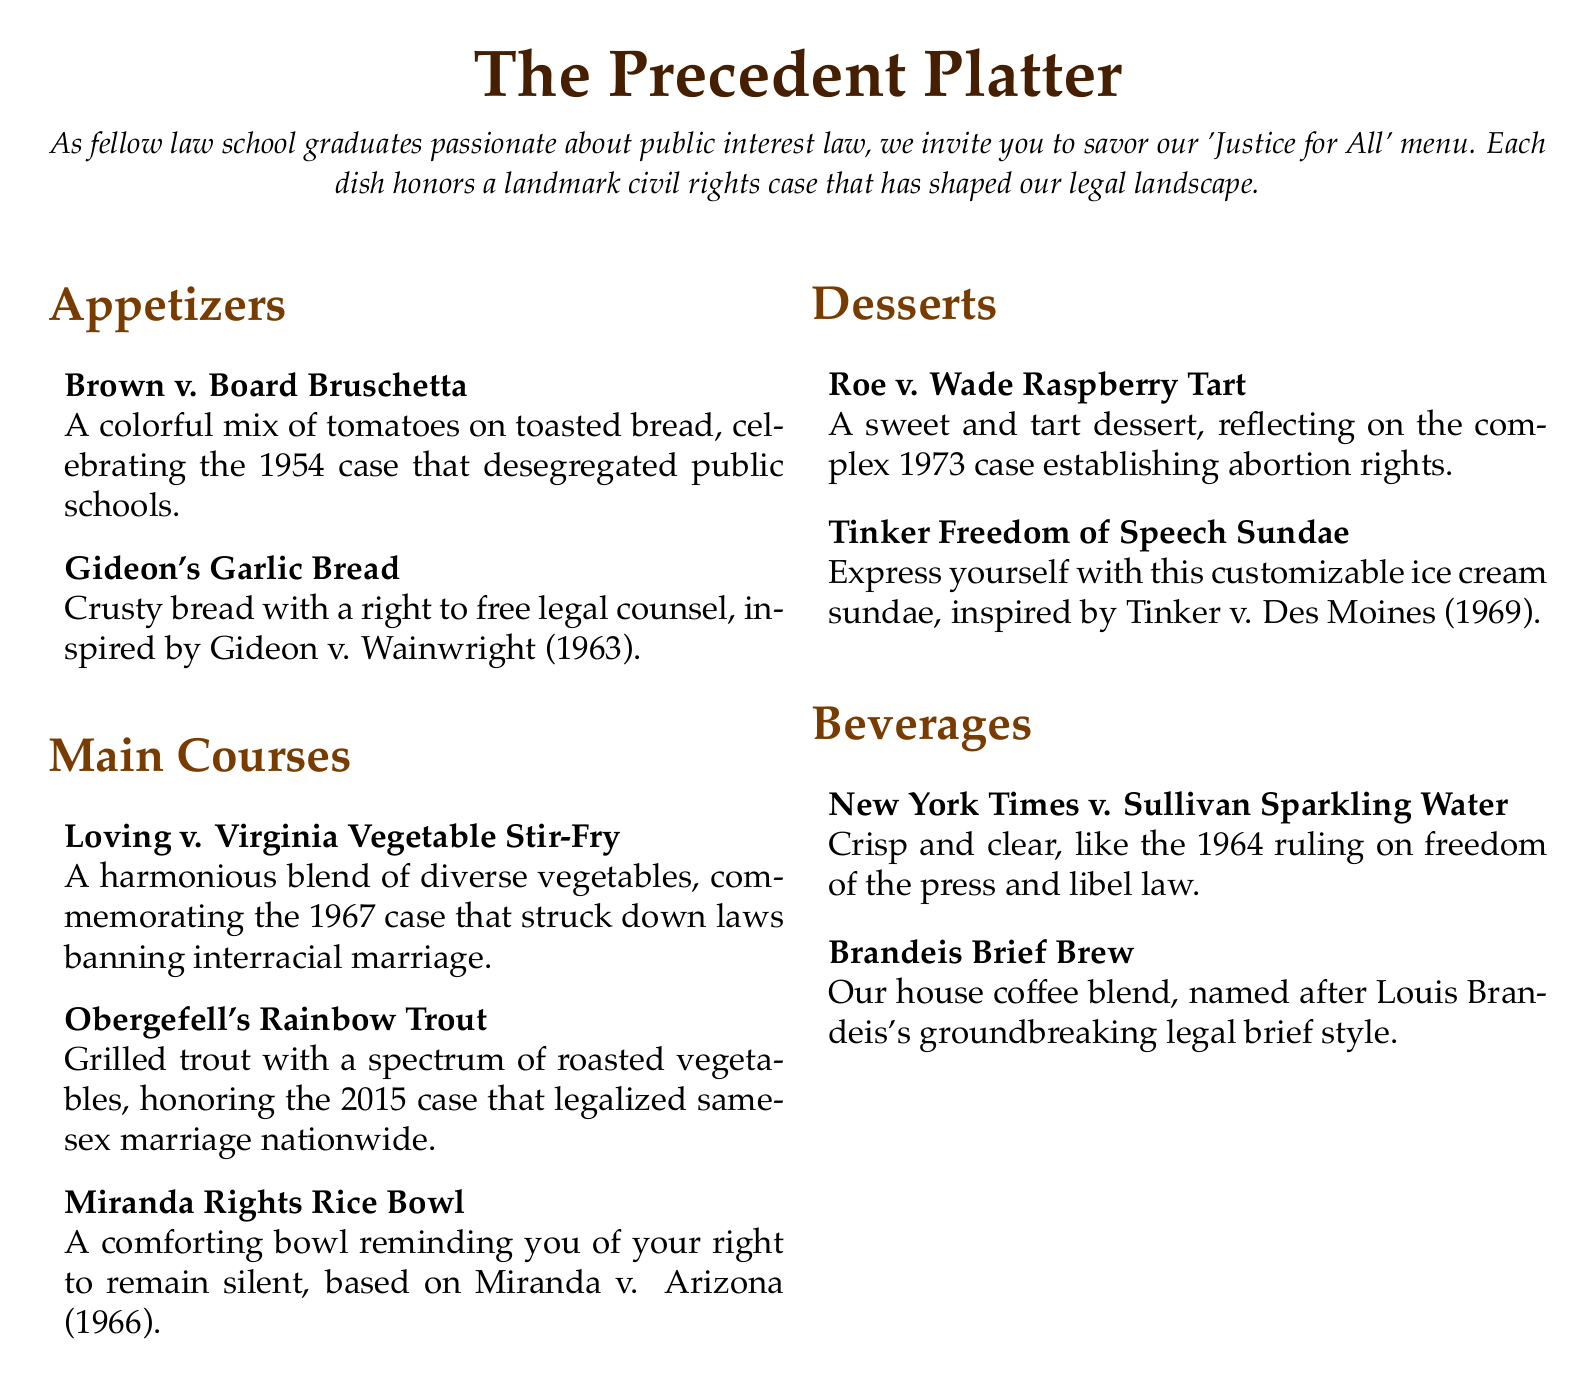What is the name of the appetizer inspired by a case that desegregated public schools? The appetizer named after the case that desegregated public schools is "Brown v. Board Bruschetta."
Answer: Brown v. Board Bruschetta Which dessert reflects on the complex case establishing abortion rights? The dessert that reflects on the case establishing abortion rights is "Roe v. Wade Raspberry Tart."
Answer: Roe v. Wade Raspberry Tart What year was Gideon v. Wainwright decided? The year Gideon v. Wainwright was decided is 1963.
Answer: 1963 How many main courses are featured in the menu? The menu features three main courses: Loving v. Virginia Vegetable Stir-Fry, Obergefell's Rainbow Trout, and Miranda Rights Rice Bowl.
Answer: Three What does the Tinker Freedom of Speech Sundae allow you to do? The Tinker Freedom of Speech Sundae allows you to express yourself with a customizable ice cream sundae.
Answer: Customize Which beverage is named after a 1964 ruling on freedom of the press? The beverage named after the 1964 ruling on freedom of the press is "New York Times v. Sullivan Sparkling Water."
Answer: New York Times v. Sullivan Sparkling Water What is the color theme of the section headers in the menu? The color theme of the section headers in the menu is a shade of brown.
Answer: Brown Which landmark case is commemorated by the dish named "Obergefell's Rainbow Trout"? The dish named "Obergefell's Rainbow Trout" commemorates the landmark case that legalized same-sex marriage.
Answer: Obergefell v. Hodges 